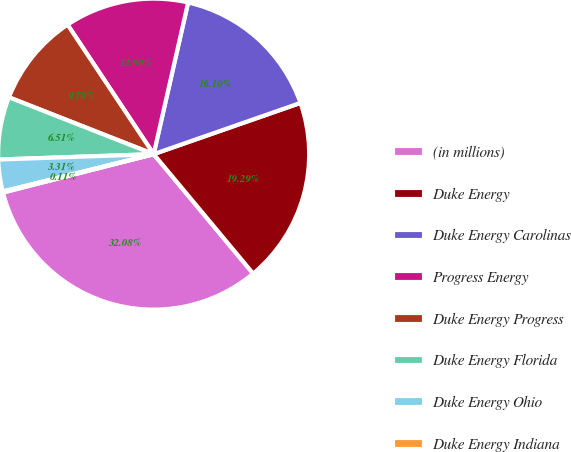Convert chart to OTSL. <chart><loc_0><loc_0><loc_500><loc_500><pie_chart><fcel>(in millions)<fcel>Duke Energy<fcel>Duke Energy Carolinas<fcel>Progress Energy<fcel>Duke Energy Progress<fcel>Duke Energy Florida<fcel>Duke Energy Ohio<fcel>Duke Energy Indiana<nl><fcel>32.08%<fcel>19.29%<fcel>16.1%<fcel>12.9%<fcel>9.7%<fcel>6.51%<fcel>3.31%<fcel>0.11%<nl></chart> 